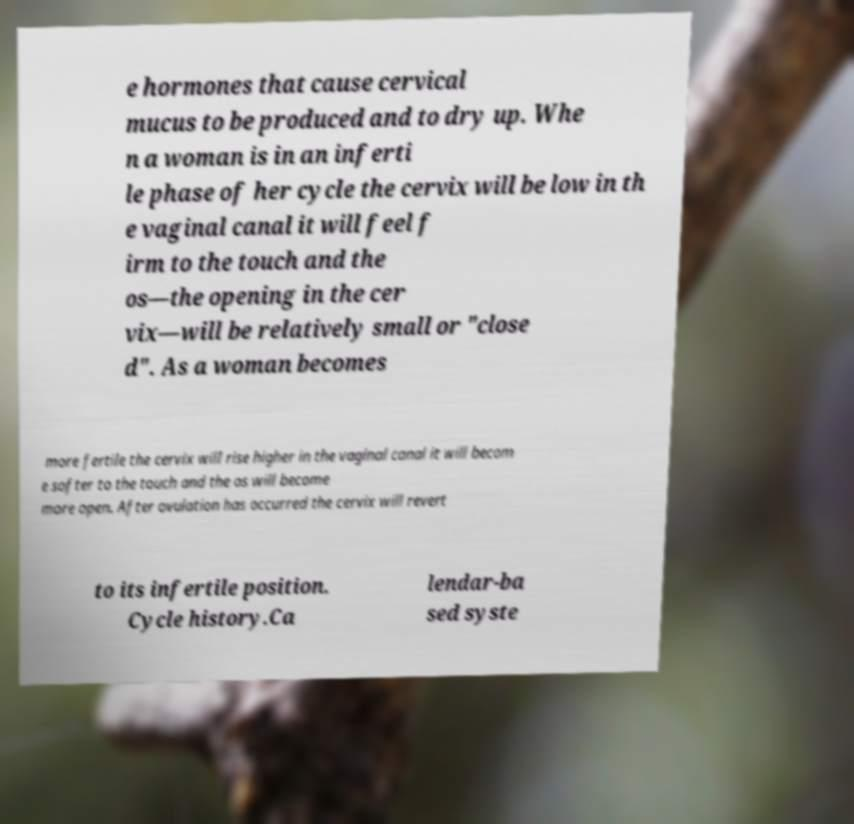Could you assist in decoding the text presented in this image and type it out clearly? e hormones that cause cervical mucus to be produced and to dry up. Whe n a woman is in an inferti le phase of her cycle the cervix will be low in th e vaginal canal it will feel f irm to the touch and the os—the opening in the cer vix—will be relatively small or "close d". As a woman becomes more fertile the cervix will rise higher in the vaginal canal it will becom e softer to the touch and the os will become more open. After ovulation has occurred the cervix will revert to its infertile position. Cycle history.Ca lendar-ba sed syste 